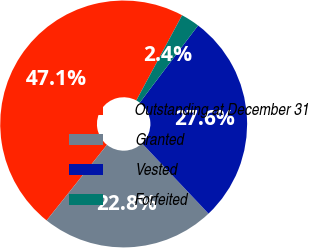Convert chart. <chart><loc_0><loc_0><loc_500><loc_500><pie_chart><fcel>Outstanding at December 31<fcel>Granted<fcel>Vested<fcel>Forfeited<nl><fcel>47.13%<fcel>22.79%<fcel>27.64%<fcel>2.45%<nl></chart> 